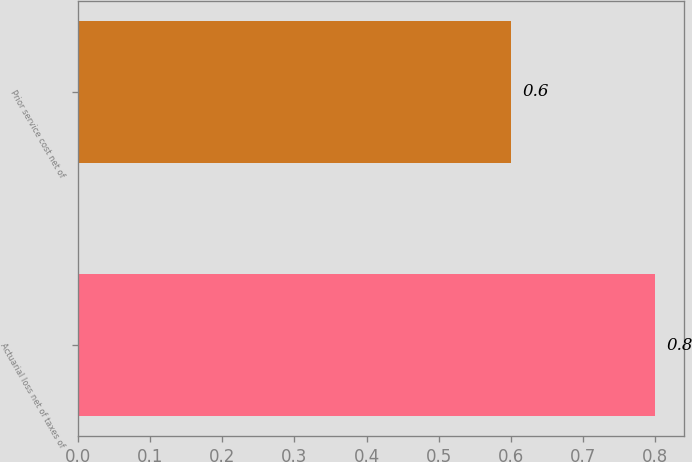Convert chart. <chart><loc_0><loc_0><loc_500><loc_500><bar_chart><fcel>Actuarial loss net of taxes of<fcel>Prior service cost net of<nl><fcel>0.8<fcel>0.6<nl></chart> 